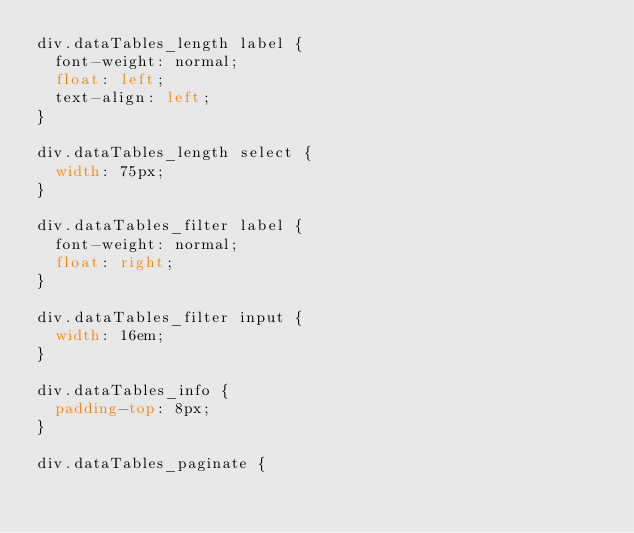Convert code to text. <code><loc_0><loc_0><loc_500><loc_500><_CSS_>div.dataTables_length label {
	font-weight: normal;
	float: left;
	text-align: left;
}

div.dataTables_length select {
	width: 75px;
}

div.dataTables_filter label {
	font-weight: normal;
	float: right;
}

div.dataTables_filter input {
	width: 16em;
}

div.dataTables_info {
	padding-top: 8px;
}

div.dataTables_paginate {</code> 